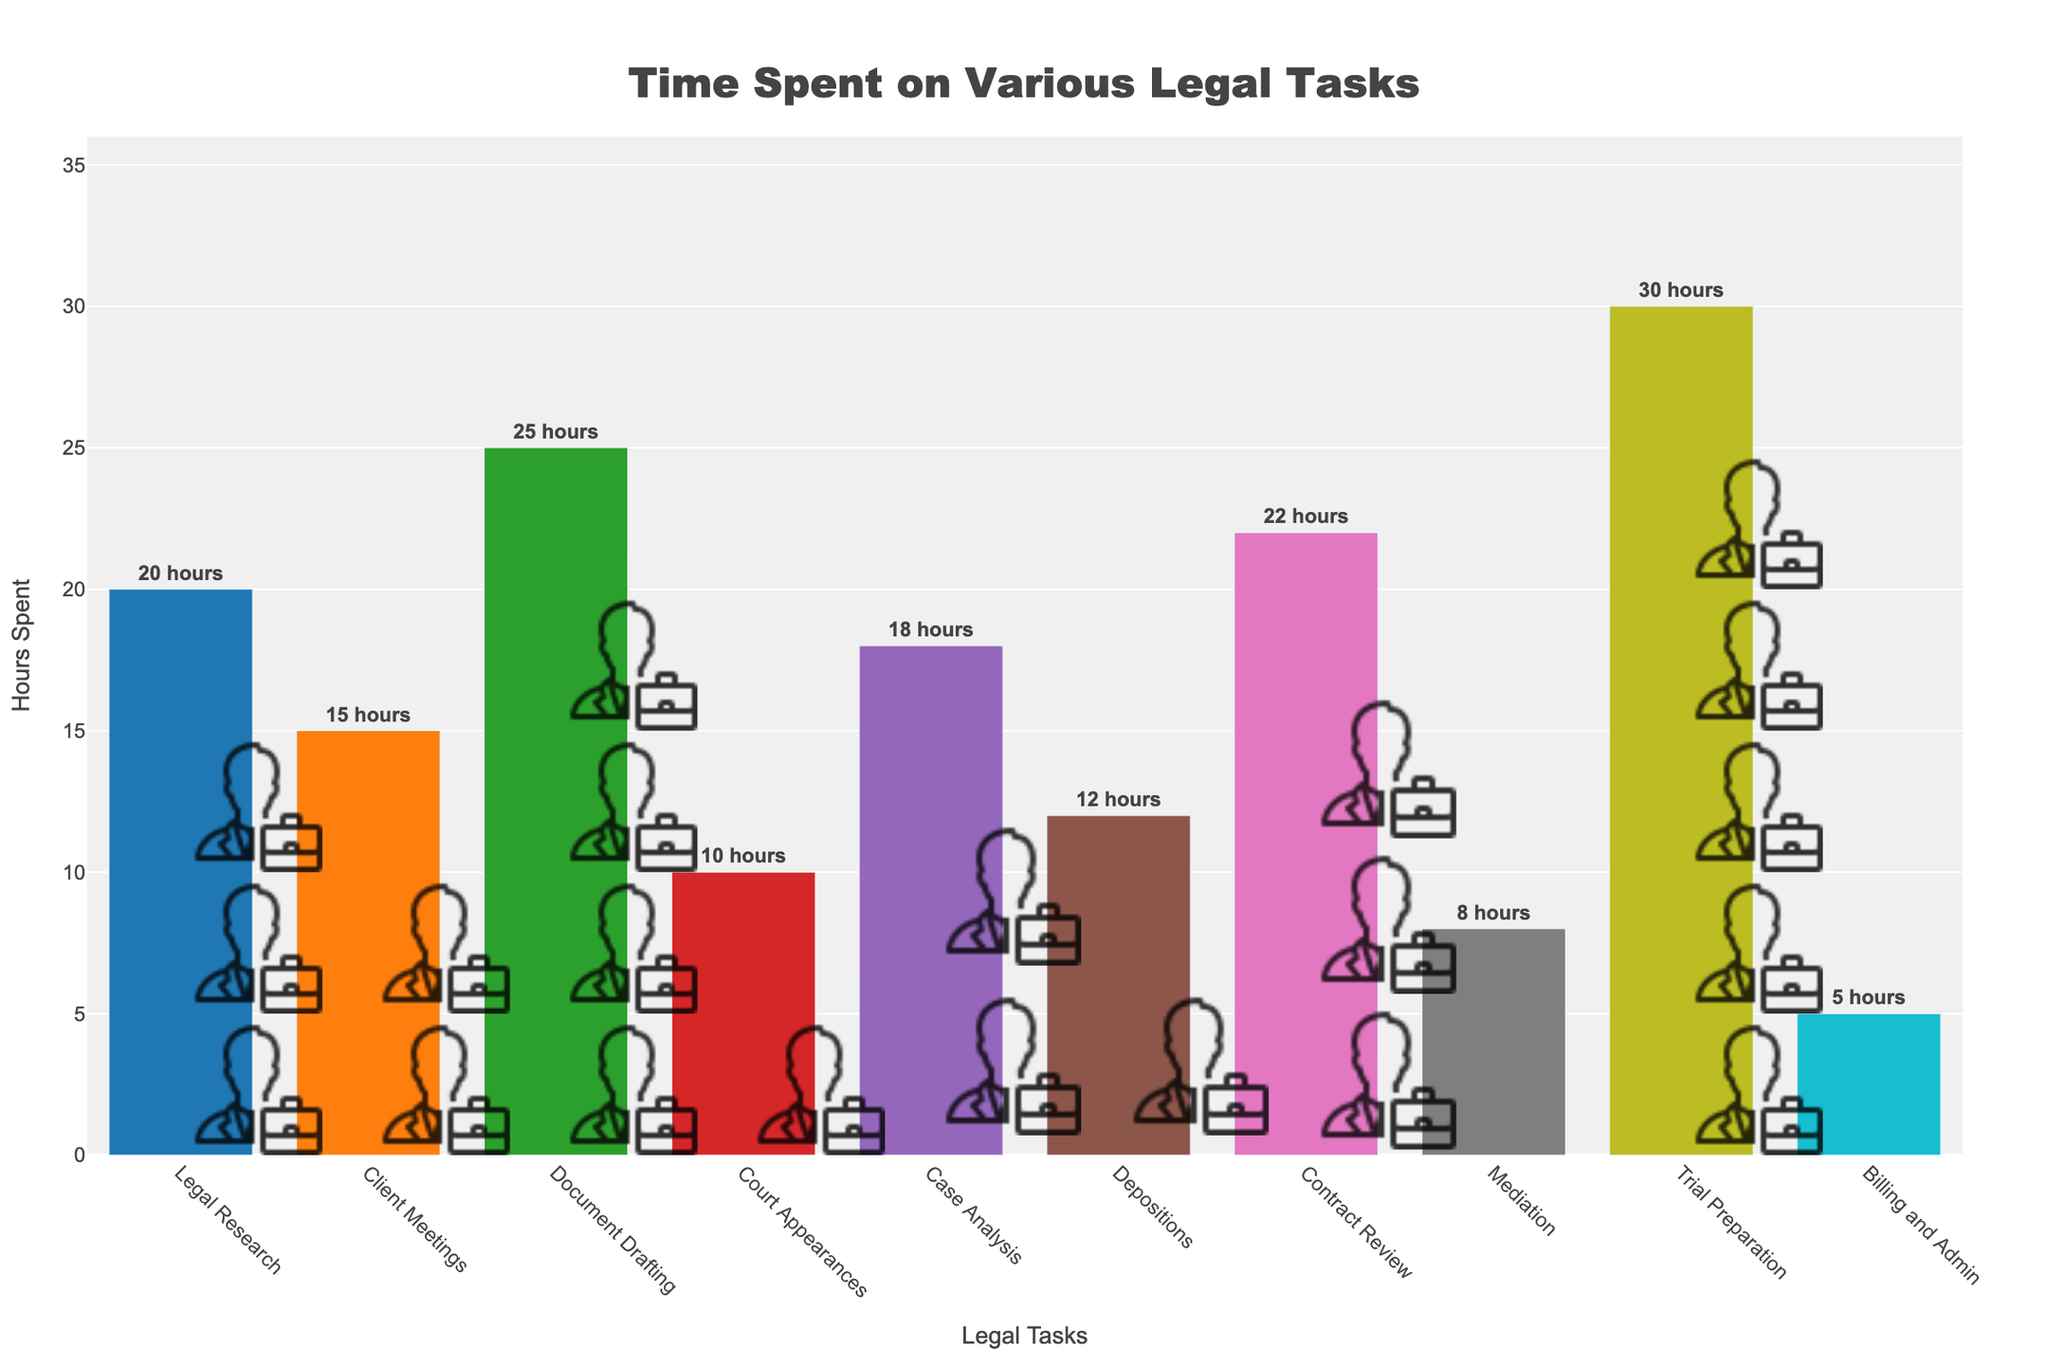What's the title of the figure? The figure prominently displays a title at the top. Reading it directly provides the title.
Answer: Time Spent on Various Legal Tasks How many lawyer icons represent Document Drafting? The figure uses icons to represent hours. Counting the icons next to "Document Drafting" yields the number.
Answer: 5 Which task has the least amount of time spent? Observing the length of bars and reading the task names, "Billing and Admin" has the shortest bar.
Answer: Billing and Admin How many hours are spent on Contract Review? The bar labeled "Contract Review" extends to a specific value on the y-axis, and the number of lawyer icons can confirm it.
Answer: 22 Compare the time spent on Legal Research and Client Meetings. Which one took more time and by how many hours? By comparing the bar lengths for "Legal Research" and "Client Meetings," we see that Legal Research has a longer bar. Subtracting the hours gives us the difference.
Answer: Legal Research by 5 hours What is the total time spent on Mediation and Trial Preparation combined? Adding the hours from the bars labeled "Mediation" (8 hours) and "Trial Preparation" (30 hours) gives the total.
Answer: 38 hours Is Court Appearances less than half of Document Drafting? Comparing the bar lengths, Court Appearances (10 hours) is less than half of Document Drafting (25 hours).
Answer: Yes What is the average time spent on all tasks? Summing up all the hours for each task and dividing by the number of tasks (10) gives the average. (20+15+25+10+18+12+22+8+30+5)/10 = 16.5
Answer: 16.5 hours Which task has the second highest number of icons? By counting the icons for each task, the second highest, after Trial Preparation, has 5 icons for "Document Drafting."
Answer: Document Drafting List all tasks with more than 4 lawyer icons. Counting the icons for each task visually, identify tasks with more than 4 icons and list them.
Answer: Document Drafting, Contract Review, Trial Preparation 